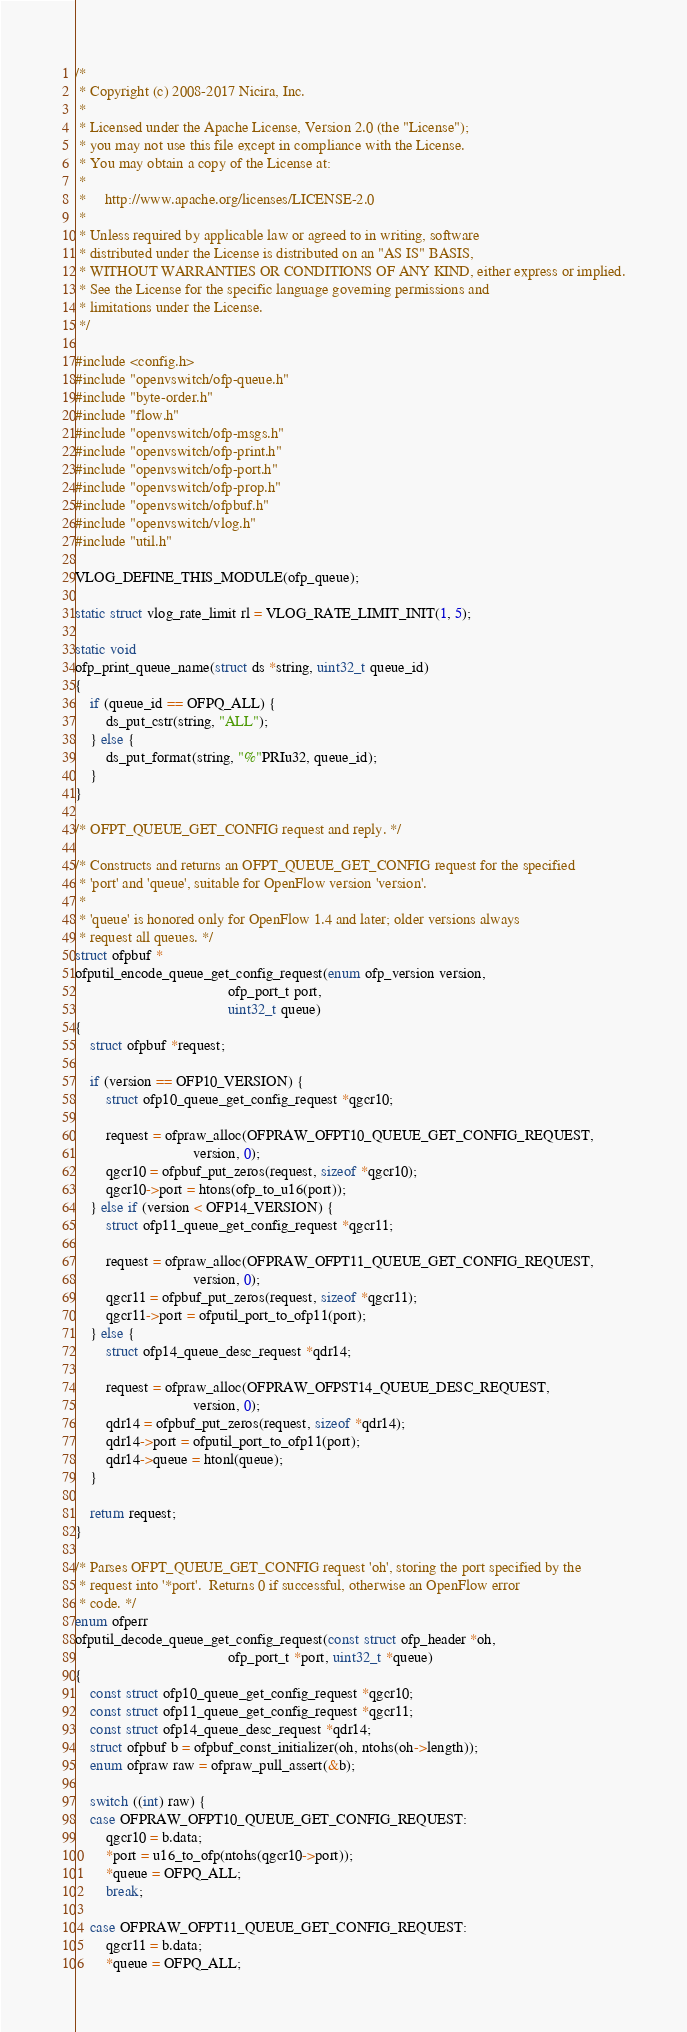Convert code to text. <code><loc_0><loc_0><loc_500><loc_500><_C_>/*
 * Copyright (c) 2008-2017 Nicira, Inc.
 *
 * Licensed under the Apache License, Version 2.0 (the "License");
 * you may not use this file except in compliance with the License.
 * You may obtain a copy of the License at:
 *
 *     http://www.apache.org/licenses/LICENSE-2.0
 *
 * Unless required by applicable law or agreed to in writing, software
 * distributed under the License is distributed on an "AS IS" BASIS,
 * WITHOUT WARRANTIES OR CONDITIONS OF ANY KIND, either express or implied.
 * See the License for the specific language governing permissions and
 * limitations under the License.
 */

#include <config.h>
#include "openvswitch/ofp-queue.h"
#include "byte-order.h"
#include "flow.h"
#include "openvswitch/ofp-msgs.h"
#include "openvswitch/ofp-print.h"
#include "openvswitch/ofp-port.h"
#include "openvswitch/ofp-prop.h"
#include "openvswitch/ofpbuf.h"
#include "openvswitch/vlog.h"
#include "util.h"

VLOG_DEFINE_THIS_MODULE(ofp_queue);

static struct vlog_rate_limit rl = VLOG_RATE_LIMIT_INIT(1, 5);

static void
ofp_print_queue_name(struct ds *string, uint32_t queue_id)
{
    if (queue_id == OFPQ_ALL) {
        ds_put_cstr(string, "ALL");
    } else {
        ds_put_format(string, "%"PRIu32, queue_id);
    }
}

/* OFPT_QUEUE_GET_CONFIG request and reply. */

/* Constructs and returns an OFPT_QUEUE_GET_CONFIG request for the specified
 * 'port' and 'queue', suitable for OpenFlow version 'version'.
 *
 * 'queue' is honored only for OpenFlow 1.4 and later; older versions always
 * request all queues. */
struct ofpbuf *
ofputil_encode_queue_get_config_request(enum ofp_version version,
                                        ofp_port_t port,
                                        uint32_t queue)
{
    struct ofpbuf *request;

    if (version == OFP10_VERSION) {
        struct ofp10_queue_get_config_request *qgcr10;

        request = ofpraw_alloc(OFPRAW_OFPT10_QUEUE_GET_CONFIG_REQUEST,
                               version, 0);
        qgcr10 = ofpbuf_put_zeros(request, sizeof *qgcr10);
        qgcr10->port = htons(ofp_to_u16(port));
    } else if (version < OFP14_VERSION) {
        struct ofp11_queue_get_config_request *qgcr11;

        request = ofpraw_alloc(OFPRAW_OFPT11_QUEUE_GET_CONFIG_REQUEST,
                               version, 0);
        qgcr11 = ofpbuf_put_zeros(request, sizeof *qgcr11);
        qgcr11->port = ofputil_port_to_ofp11(port);
    } else {
        struct ofp14_queue_desc_request *qdr14;

        request = ofpraw_alloc(OFPRAW_OFPST14_QUEUE_DESC_REQUEST,
                               version, 0);
        qdr14 = ofpbuf_put_zeros(request, sizeof *qdr14);
        qdr14->port = ofputil_port_to_ofp11(port);
        qdr14->queue = htonl(queue);
    }

    return request;
}

/* Parses OFPT_QUEUE_GET_CONFIG request 'oh', storing the port specified by the
 * request into '*port'.  Returns 0 if successful, otherwise an OpenFlow error
 * code. */
enum ofperr
ofputil_decode_queue_get_config_request(const struct ofp_header *oh,
                                        ofp_port_t *port, uint32_t *queue)
{
    const struct ofp10_queue_get_config_request *qgcr10;
    const struct ofp11_queue_get_config_request *qgcr11;
    const struct ofp14_queue_desc_request *qdr14;
    struct ofpbuf b = ofpbuf_const_initializer(oh, ntohs(oh->length));
    enum ofpraw raw = ofpraw_pull_assert(&b);

    switch ((int) raw) {
    case OFPRAW_OFPT10_QUEUE_GET_CONFIG_REQUEST:
        qgcr10 = b.data;
        *port = u16_to_ofp(ntohs(qgcr10->port));
        *queue = OFPQ_ALL;
        break;

    case OFPRAW_OFPT11_QUEUE_GET_CONFIG_REQUEST:
        qgcr11 = b.data;
        *queue = OFPQ_ALL;</code> 